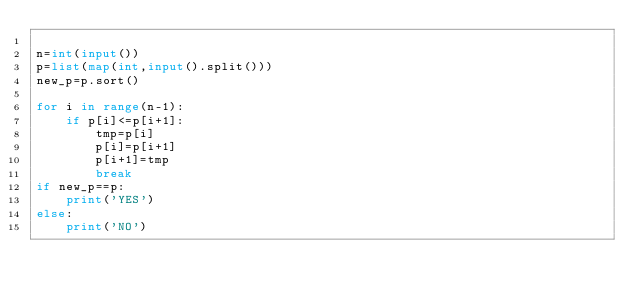Convert code to text. <code><loc_0><loc_0><loc_500><loc_500><_Python_>
n=int(input())
p=list(map(int,input().split()))
new_p=p.sort()

for i in range(n-1):
    if p[i]<=p[i+1]:
        tmp=p[i]
        p[i]=p[i+1]
        p[i+1]=tmp
        break
if new_p==p:
    print('YES')
else:
    print('NO')</code> 